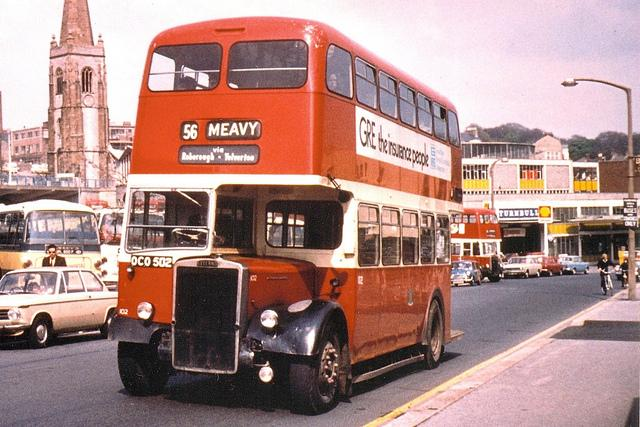Why does the vehicle have two levels? sightseeing 